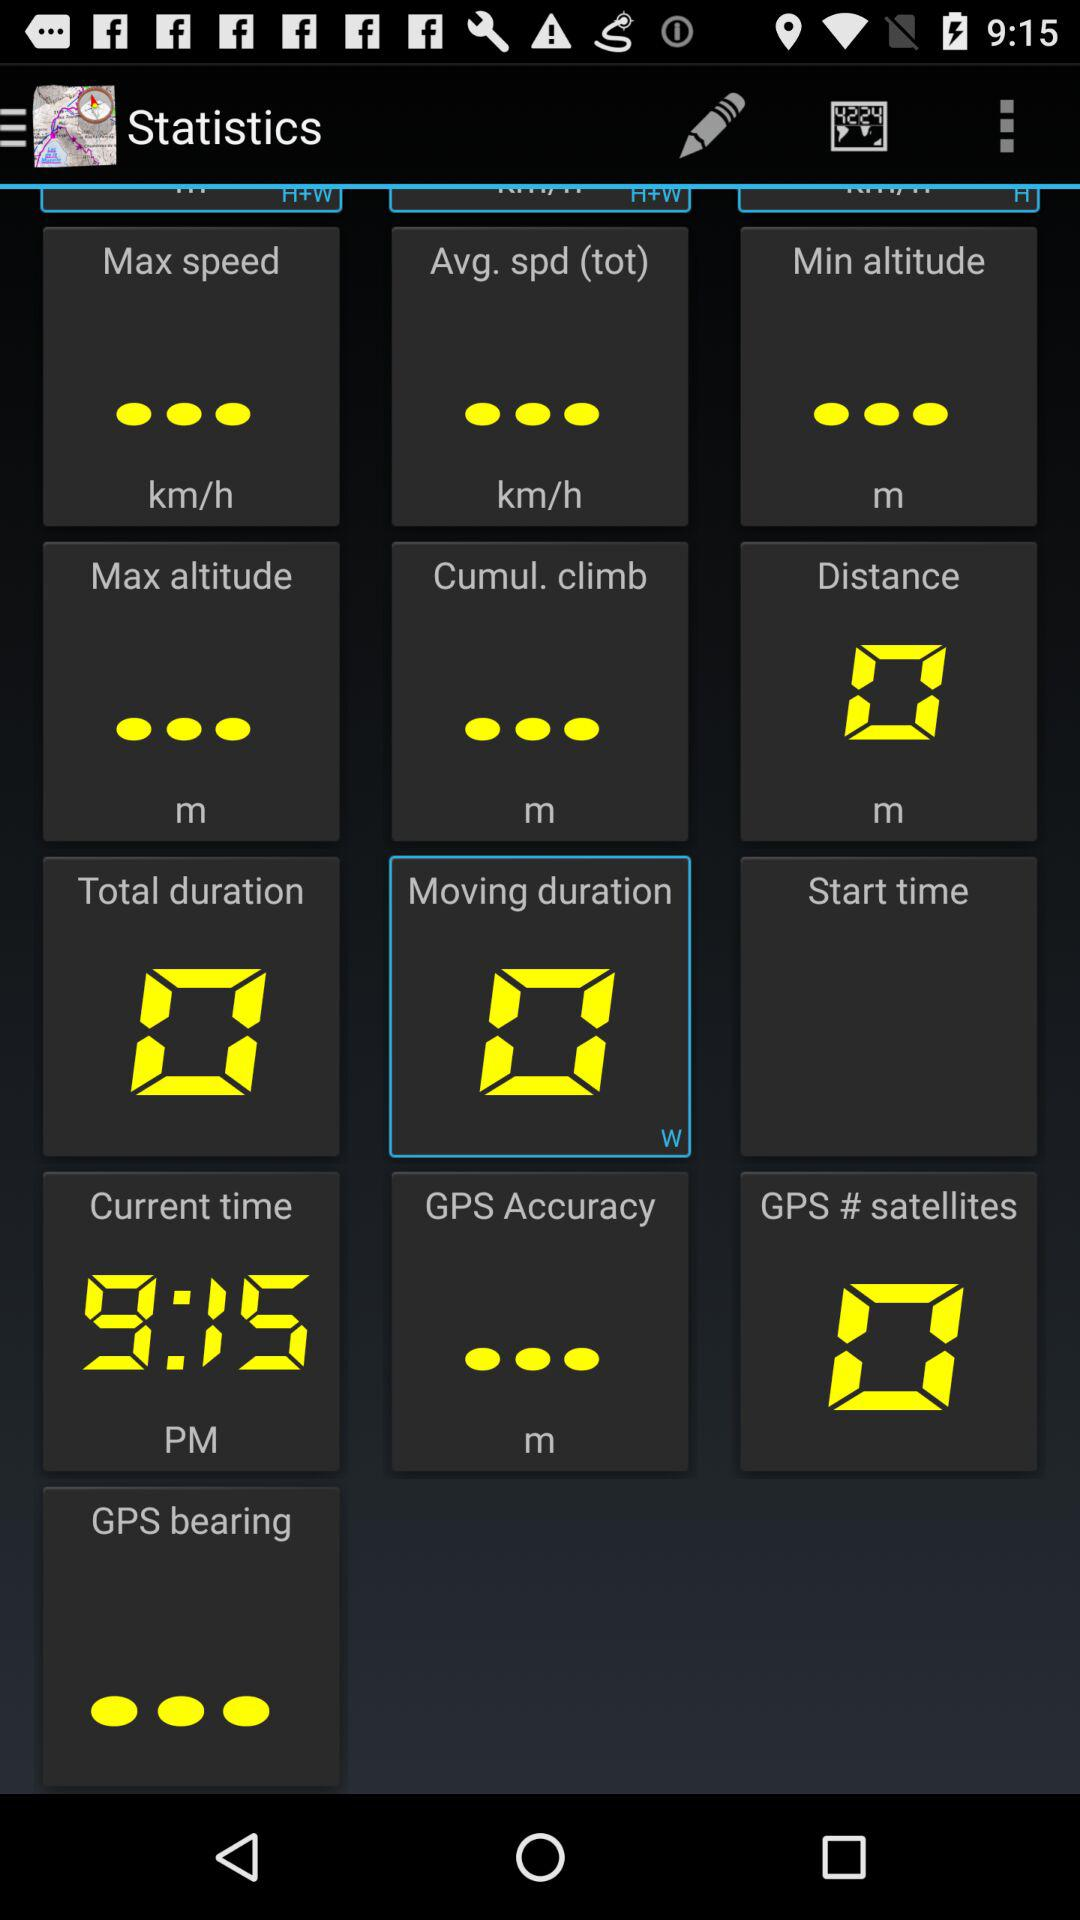What is the distance shown on the screen? The distance shown is 0 m. 